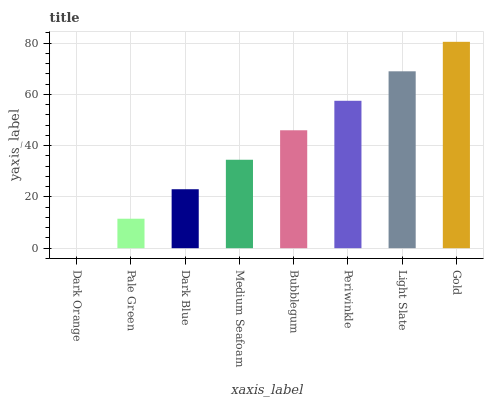Is Pale Green the minimum?
Answer yes or no. No. Is Pale Green the maximum?
Answer yes or no. No. Is Pale Green greater than Dark Orange?
Answer yes or no. Yes. Is Dark Orange less than Pale Green?
Answer yes or no. Yes. Is Dark Orange greater than Pale Green?
Answer yes or no. No. Is Pale Green less than Dark Orange?
Answer yes or no. No. Is Bubblegum the high median?
Answer yes or no. Yes. Is Medium Seafoam the low median?
Answer yes or no. Yes. Is Light Slate the high median?
Answer yes or no. No. Is Periwinkle the low median?
Answer yes or no. No. 